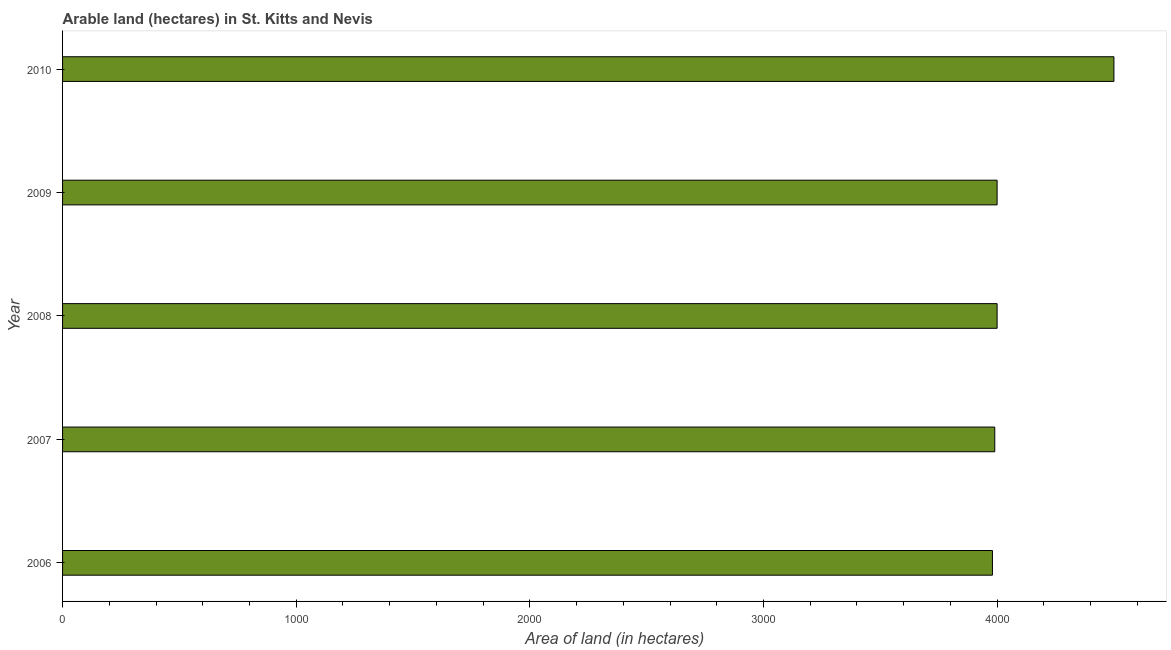Does the graph contain grids?
Your answer should be very brief. No. What is the title of the graph?
Keep it short and to the point. Arable land (hectares) in St. Kitts and Nevis. What is the label or title of the X-axis?
Offer a terse response. Area of land (in hectares). What is the label or title of the Y-axis?
Ensure brevity in your answer.  Year. What is the area of land in 2010?
Your answer should be compact. 4500. Across all years, what is the maximum area of land?
Offer a very short reply. 4500. Across all years, what is the minimum area of land?
Your answer should be very brief. 3980. What is the sum of the area of land?
Keep it short and to the point. 2.05e+04. What is the average area of land per year?
Provide a succinct answer. 4094. What is the median area of land?
Provide a succinct answer. 4000. Do a majority of the years between 2008 and 2007 (inclusive) have area of land greater than 800 hectares?
Make the answer very short. No. What is the ratio of the area of land in 2009 to that in 2010?
Give a very brief answer. 0.89. Is the difference between the area of land in 2008 and 2010 greater than the difference between any two years?
Give a very brief answer. No. What is the difference between the highest and the second highest area of land?
Offer a very short reply. 500. What is the difference between the highest and the lowest area of land?
Keep it short and to the point. 520. Are all the bars in the graph horizontal?
Provide a succinct answer. Yes. What is the difference between two consecutive major ticks on the X-axis?
Make the answer very short. 1000. What is the Area of land (in hectares) in 2006?
Your answer should be very brief. 3980. What is the Area of land (in hectares) in 2007?
Give a very brief answer. 3990. What is the Area of land (in hectares) in 2008?
Your response must be concise. 4000. What is the Area of land (in hectares) of 2009?
Make the answer very short. 4000. What is the Area of land (in hectares) of 2010?
Make the answer very short. 4500. What is the difference between the Area of land (in hectares) in 2006 and 2009?
Keep it short and to the point. -20. What is the difference between the Area of land (in hectares) in 2006 and 2010?
Your answer should be compact. -520. What is the difference between the Area of land (in hectares) in 2007 and 2009?
Ensure brevity in your answer.  -10. What is the difference between the Area of land (in hectares) in 2007 and 2010?
Your answer should be very brief. -510. What is the difference between the Area of land (in hectares) in 2008 and 2010?
Offer a very short reply. -500. What is the difference between the Area of land (in hectares) in 2009 and 2010?
Provide a succinct answer. -500. What is the ratio of the Area of land (in hectares) in 2006 to that in 2010?
Your answer should be very brief. 0.88. What is the ratio of the Area of land (in hectares) in 2007 to that in 2008?
Offer a very short reply. 1. What is the ratio of the Area of land (in hectares) in 2007 to that in 2010?
Ensure brevity in your answer.  0.89. What is the ratio of the Area of land (in hectares) in 2008 to that in 2010?
Your response must be concise. 0.89. What is the ratio of the Area of land (in hectares) in 2009 to that in 2010?
Keep it short and to the point. 0.89. 